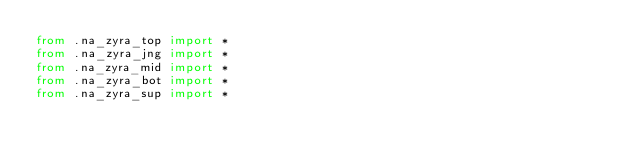Convert code to text. <code><loc_0><loc_0><loc_500><loc_500><_Python_>from .na_zyra_top import *
from .na_zyra_jng import *
from .na_zyra_mid import *
from .na_zyra_bot import *
from .na_zyra_sup import *
</code> 